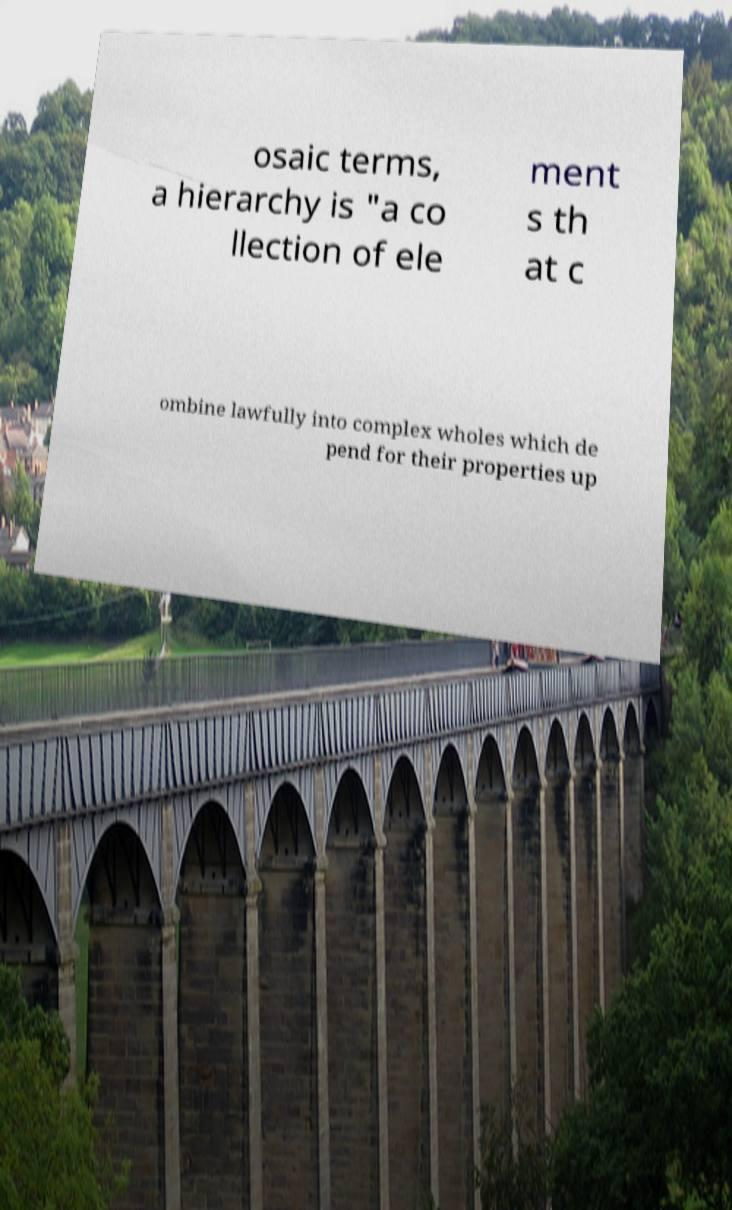There's text embedded in this image that I need extracted. Can you transcribe it verbatim? osaic terms, a hierarchy is "a co llection of ele ment s th at c ombine lawfully into complex wholes which de pend for their properties up 